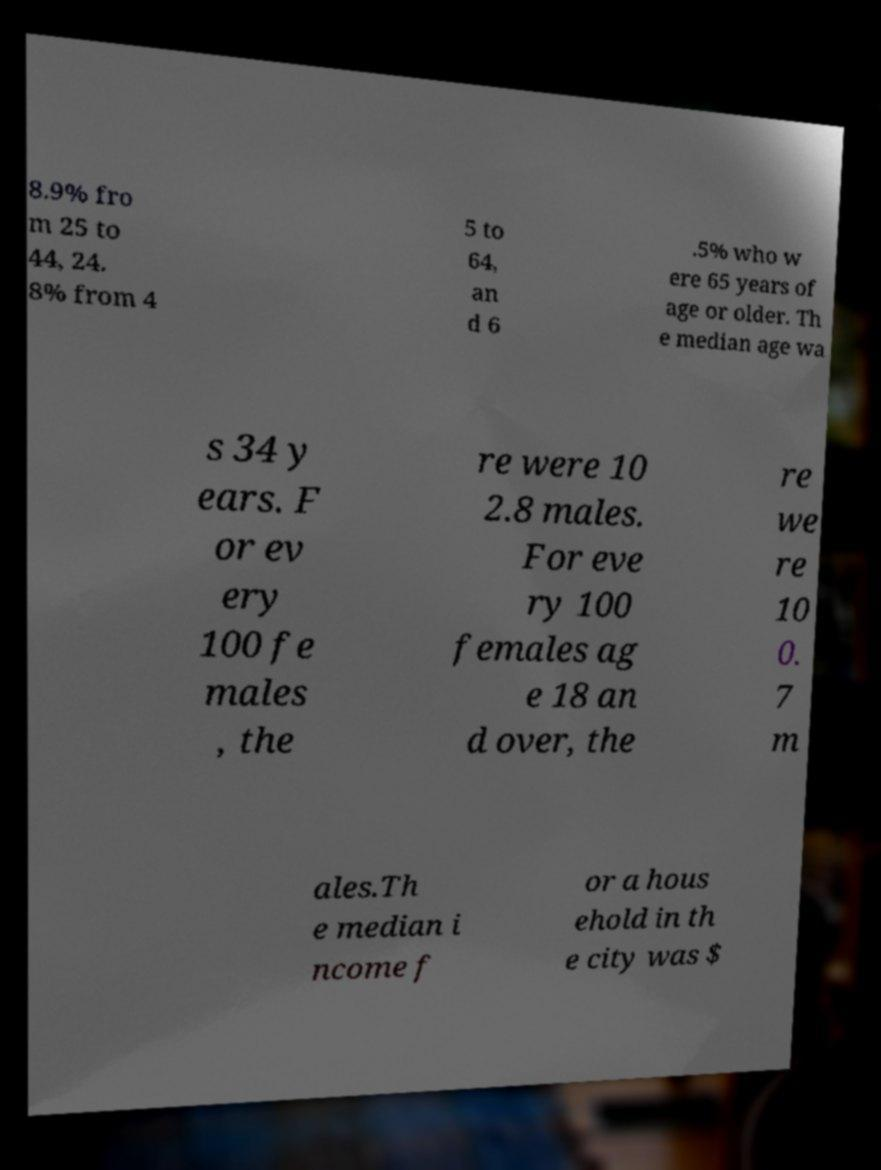Can you accurately transcribe the text from the provided image for me? 8.9% fro m 25 to 44, 24. 8% from 4 5 to 64, an d 6 .5% who w ere 65 years of age or older. Th e median age wa s 34 y ears. F or ev ery 100 fe males , the re were 10 2.8 males. For eve ry 100 females ag e 18 an d over, the re we re 10 0. 7 m ales.Th e median i ncome f or a hous ehold in th e city was $ 